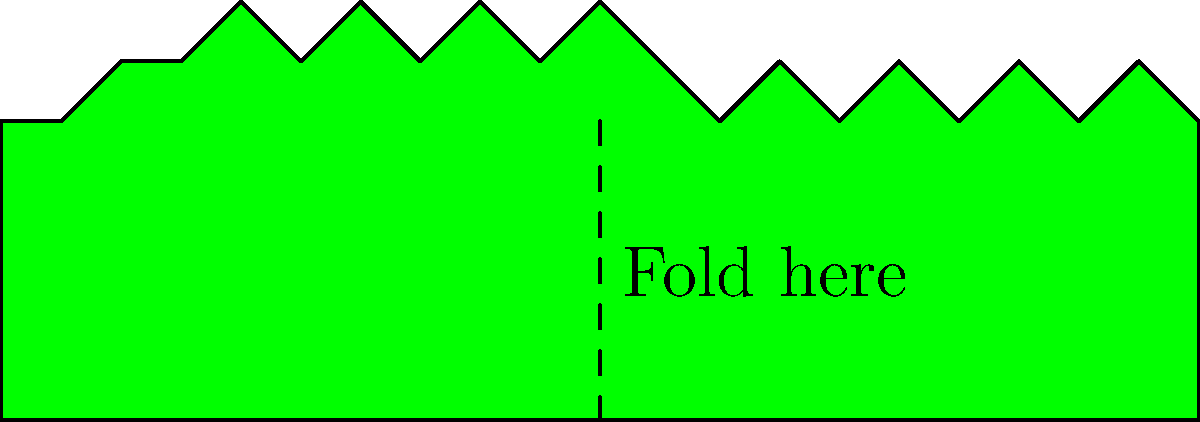If the map of Mexico shown above is folded along the dashed line, which part of the country's outline would perfectly align with the Baja California peninsula? To solve this mental folding exercise, follow these steps:

1. Visualize folding the map along the dashed line, bringing the right side over to the left.
2. The Baja California peninsula is located on the left side of the map.
3. When folded, the right side of Mexico's outline will overlap with the left side.
4. The part that aligns with Baja California should have a similar shape and size.
5. Examining the right side of the map, we can see that the coastline near Chiapas and Oaxaca has a similar shape to Baja California.
6. This southeastern region would align closely with the Baja California peninsula when folded.

The mental folding exercise demonstrates the diverse and unique geography of Mexico, highlighting the symmetry between different coastal regions of our beautiful country.
Answer: Chiapas-Oaxaca coastline 